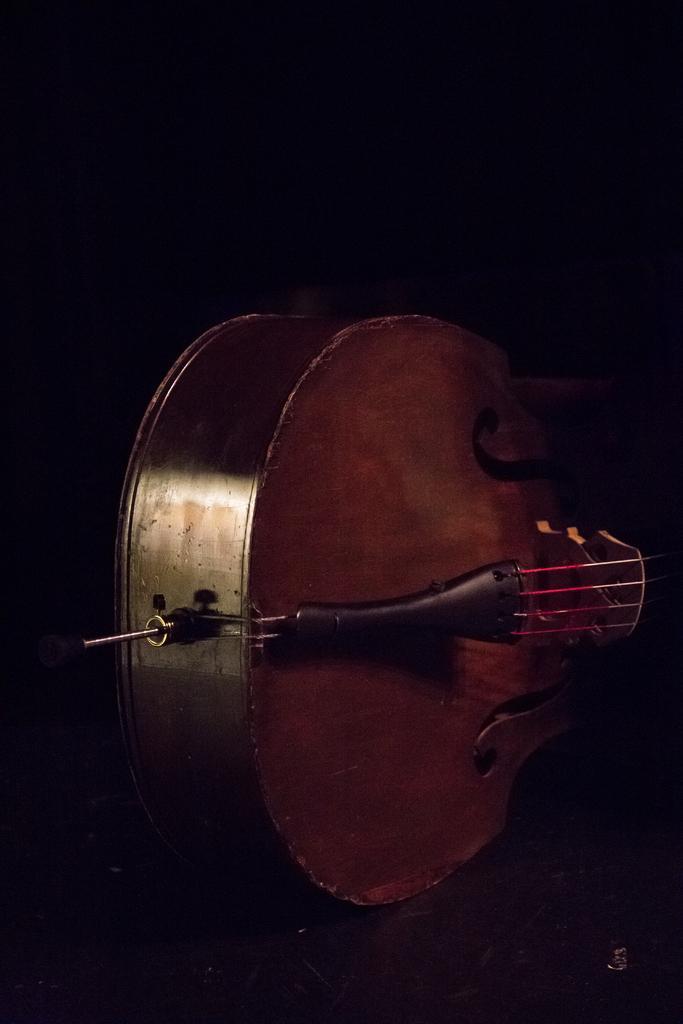In one or two sentences, can you explain what this image depicts? This picture shows a guitar having a strings, which is brown in color. In the background there is dark. 